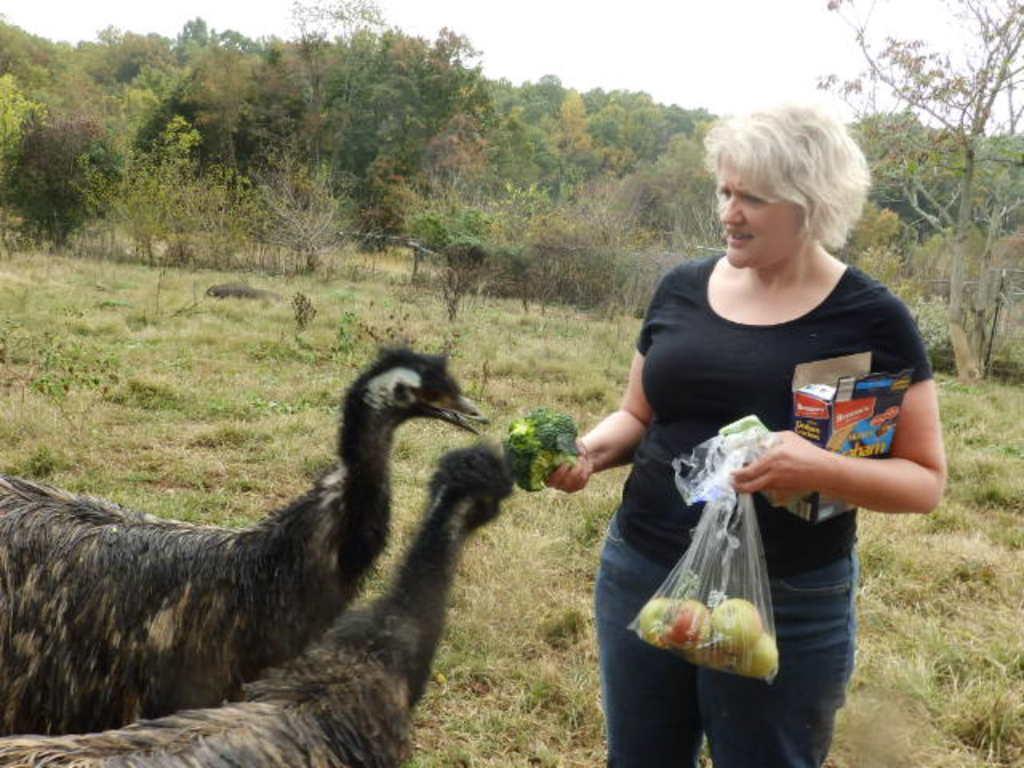Could you give a brief overview of what you see in this image? On the left side we can see two animals and on the right side we can see a woman is standing and holding fruits in a packet and a vegetable item in her hands and there is box under her arm. In the background there are plants, trees and grass on the ground and sky. 